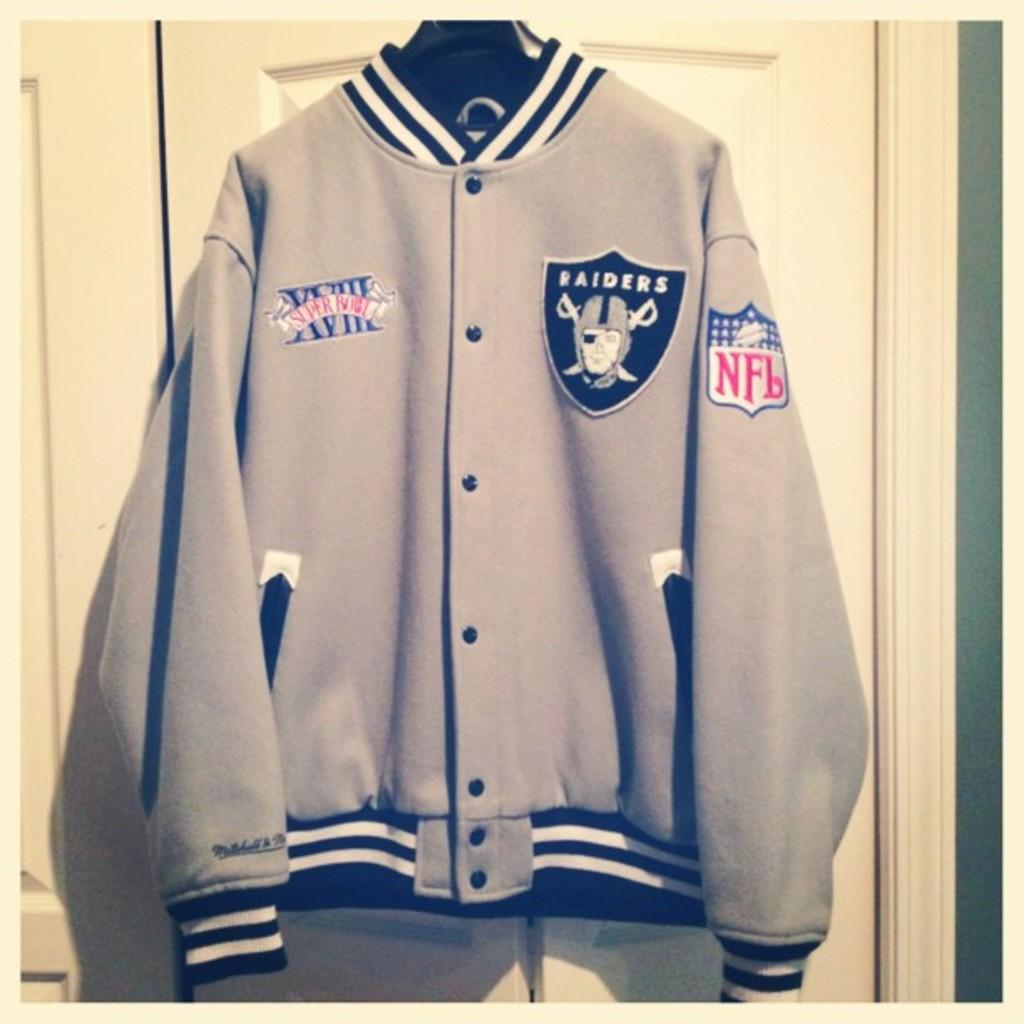<image>
Offer a succinct explanation of the picture presented. the word Raiders that is on a jacket 